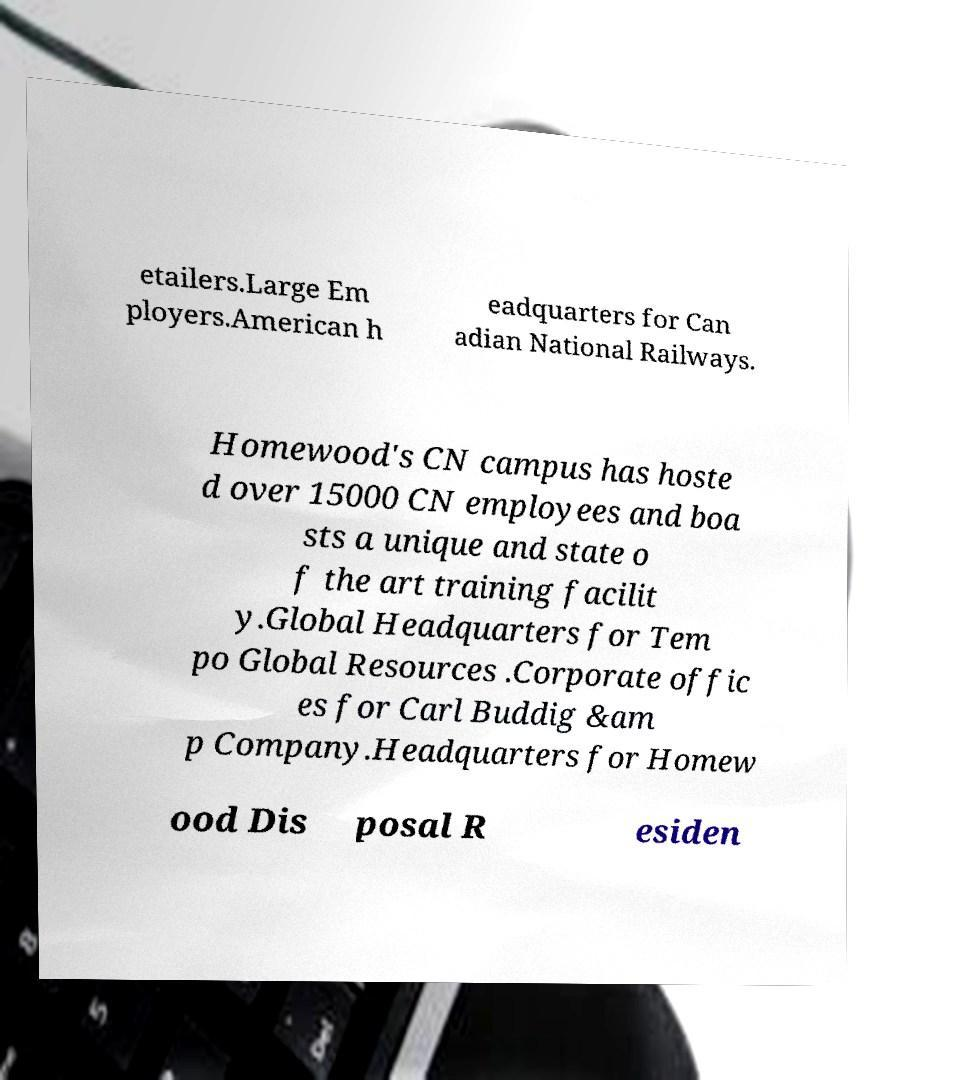Can you read and provide the text displayed in the image?This photo seems to have some interesting text. Can you extract and type it out for me? etailers.Large Em ployers.American h eadquarters for Can adian National Railways. Homewood's CN campus has hoste d over 15000 CN employees and boa sts a unique and state o f the art training facilit y.Global Headquarters for Tem po Global Resources .Corporate offic es for Carl Buddig &am p Company.Headquarters for Homew ood Dis posal R esiden 